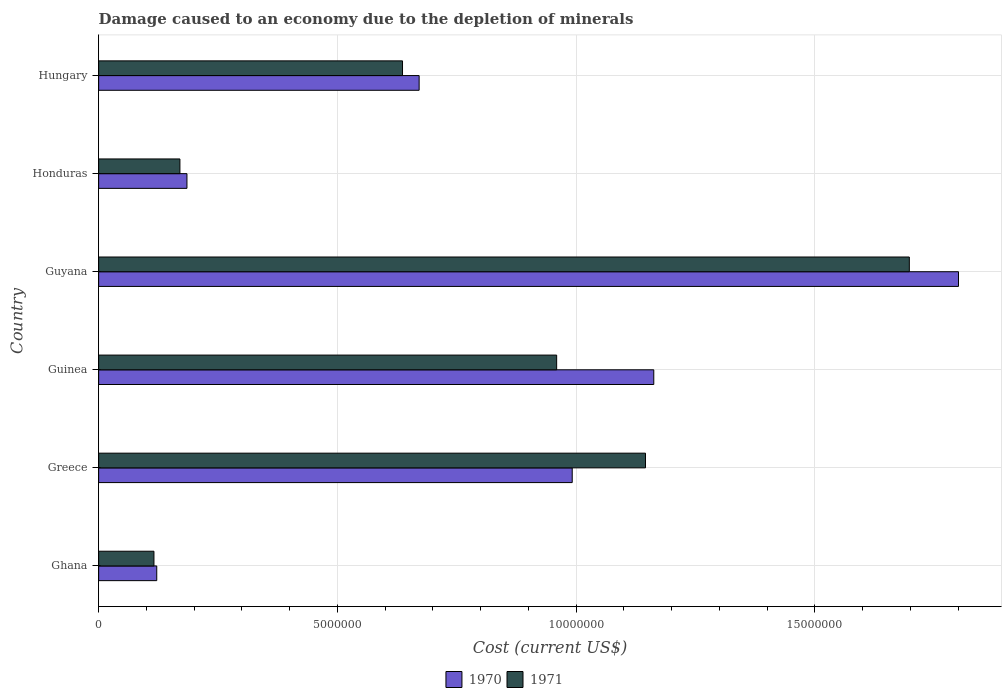How many groups of bars are there?
Give a very brief answer. 6. Are the number of bars per tick equal to the number of legend labels?
Your answer should be very brief. Yes. What is the cost of damage caused due to the depletion of minerals in 1971 in Guinea?
Offer a very short reply. 9.59e+06. Across all countries, what is the maximum cost of damage caused due to the depletion of minerals in 1971?
Your response must be concise. 1.70e+07. Across all countries, what is the minimum cost of damage caused due to the depletion of minerals in 1971?
Keep it short and to the point. 1.16e+06. In which country was the cost of damage caused due to the depletion of minerals in 1970 maximum?
Your answer should be very brief. Guyana. What is the total cost of damage caused due to the depletion of minerals in 1971 in the graph?
Your answer should be compact. 4.72e+07. What is the difference between the cost of damage caused due to the depletion of minerals in 1970 in Ghana and that in Greece?
Give a very brief answer. -8.70e+06. What is the difference between the cost of damage caused due to the depletion of minerals in 1970 in Guyana and the cost of damage caused due to the depletion of minerals in 1971 in Ghana?
Provide a short and direct response. 1.68e+07. What is the average cost of damage caused due to the depletion of minerals in 1970 per country?
Make the answer very short. 8.22e+06. What is the difference between the cost of damage caused due to the depletion of minerals in 1971 and cost of damage caused due to the depletion of minerals in 1970 in Greece?
Offer a terse response. 1.53e+06. In how many countries, is the cost of damage caused due to the depletion of minerals in 1971 greater than 1000000 US$?
Ensure brevity in your answer.  6. What is the ratio of the cost of damage caused due to the depletion of minerals in 1971 in Ghana to that in Honduras?
Make the answer very short. 0.68. Is the cost of damage caused due to the depletion of minerals in 1971 in Honduras less than that in Hungary?
Keep it short and to the point. Yes. Is the difference between the cost of damage caused due to the depletion of minerals in 1971 in Guyana and Hungary greater than the difference between the cost of damage caused due to the depletion of minerals in 1970 in Guyana and Hungary?
Give a very brief answer. No. What is the difference between the highest and the second highest cost of damage caused due to the depletion of minerals in 1971?
Keep it short and to the point. 5.52e+06. What is the difference between the highest and the lowest cost of damage caused due to the depletion of minerals in 1970?
Offer a very short reply. 1.68e+07. In how many countries, is the cost of damage caused due to the depletion of minerals in 1970 greater than the average cost of damage caused due to the depletion of minerals in 1970 taken over all countries?
Your response must be concise. 3. How many bars are there?
Your answer should be very brief. 12. What is the difference between two consecutive major ticks on the X-axis?
Your answer should be very brief. 5.00e+06. Are the values on the major ticks of X-axis written in scientific E-notation?
Offer a terse response. No. Does the graph contain grids?
Provide a succinct answer. Yes. Where does the legend appear in the graph?
Give a very brief answer. Bottom center. How many legend labels are there?
Ensure brevity in your answer.  2. What is the title of the graph?
Keep it short and to the point. Damage caused to an economy due to the depletion of minerals. What is the label or title of the X-axis?
Provide a short and direct response. Cost (current US$). What is the label or title of the Y-axis?
Give a very brief answer. Country. What is the Cost (current US$) of 1970 in Ghana?
Your answer should be very brief. 1.22e+06. What is the Cost (current US$) in 1971 in Ghana?
Your answer should be very brief. 1.16e+06. What is the Cost (current US$) in 1970 in Greece?
Offer a very short reply. 9.92e+06. What is the Cost (current US$) in 1971 in Greece?
Give a very brief answer. 1.15e+07. What is the Cost (current US$) in 1970 in Guinea?
Offer a very short reply. 1.16e+07. What is the Cost (current US$) of 1971 in Guinea?
Make the answer very short. 9.59e+06. What is the Cost (current US$) in 1970 in Guyana?
Ensure brevity in your answer.  1.80e+07. What is the Cost (current US$) in 1971 in Guyana?
Ensure brevity in your answer.  1.70e+07. What is the Cost (current US$) in 1970 in Honduras?
Offer a terse response. 1.85e+06. What is the Cost (current US$) in 1971 in Honduras?
Make the answer very short. 1.70e+06. What is the Cost (current US$) in 1970 in Hungary?
Keep it short and to the point. 6.71e+06. What is the Cost (current US$) in 1971 in Hungary?
Your answer should be compact. 6.36e+06. Across all countries, what is the maximum Cost (current US$) in 1970?
Make the answer very short. 1.80e+07. Across all countries, what is the maximum Cost (current US$) in 1971?
Ensure brevity in your answer.  1.70e+07. Across all countries, what is the minimum Cost (current US$) of 1970?
Provide a short and direct response. 1.22e+06. Across all countries, what is the minimum Cost (current US$) of 1971?
Keep it short and to the point. 1.16e+06. What is the total Cost (current US$) in 1970 in the graph?
Offer a very short reply. 4.93e+07. What is the total Cost (current US$) in 1971 in the graph?
Keep it short and to the point. 4.72e+07. What is the difference between the Cost (current US$) in 1970 in Ghana and that in Greece?
Make the answer very short. -8.70e+06. What is the difference between the Cost (current US$) in 1971 in Ghana and that in Greece?
Offer a terse response. -1.03e+07. What is the difference between the Cost (current US$) in 1970 in Ghana and that in Guinea?
Your response must be concise. -1.04e+07. What is the difference between the Cost (current US$) of 1971 in Ghana and that in Guinea?
Make the answer very short. -8.43e+06. What is the difference between the Cost (current US$) in 1970 in Ghana and that in Guyana?
Offer a very short reply. -1.68e+07. What is the difference between the Cost (current US$) of 1971 in Ghana and that in Guyana?
Keep it short and to the point. -1.58e+07. What is the difference between the Cost (current US$) of 1970 in Ghana and that in Honduras?
Your answer should be compact. -6.33e+05. What is the difference between the Cost (current US$) in 1971 in Ghana and that in Honduras?
Ensure brevity in your answer.  -5.44e+05. What is the difference between the Cost (current US$) in 1970 in Ghana and that in Hungary?
Make the answer very short. -5.49e+06. What is the difference between the Cost (current US$) in 1971 in Ghana and that in Hungary?
Offer a very short reply. -5.20e+06. What is the difference between the Cost (current US$) of 1970 in Greece and that in Guinea?
Make the answer very short. -1.71e+06. What is the difference between the Cost (current US$) in 1971 in Greece and that in Guinea?
Provide a succinct answer. 1.86e+06. What is the difference between the Cost (current US$) in 1970 in Greece and that in Guyana?
Give a very brief answer. -8.09e+06. What is the difference between the Cost (current US$) of 1971 in Greece and that in Guyana?
Keep it short and to the point. -5.52e+06. What is the difference between the Cost (current US$) of 1970 in Greece and that in Honduras?
Your answer should be very brief. 8.07e+06. What is the difference between the Cost (current US$) in 1971 in Greece and that in Honduras?
Keep it short and to the point. 9.75e+06. What is the difference between the Cost (current US$) of 1970 in Greece and that in Hungary?
Provide a short and direct response. 3.21e+06. What is the difference between the Cost (current US$) of 1971 in Greece and that in Hungary?
Keep it short and to the point. 5.09e+06. What is the difference between the Cost (current US$) in 1970 in Guinea and that in Guyana?
Ensure brevity in your answer.  -6.38e+06. What is the difference between the Cost (current US$) of 1971 in Guinea and that in Guyana?
Give a very brief answer. -7.38e+06. What is the difference between the Cost (current US$) in 1970 in Guinea and that in Honduras?
Provide a short and direct response. 9.78e+06. What is the difference between the Cost (current US$) in 1971 in Guinea and that in Honduras?
Ensure brevity in your answer.  7.89e+06. What is the difference between the Cost (current US$) of 1970 in Guinea and that in Hungary?
Your response must be concise. 4.91e+06. What is the difference between the Cost (current US$) in 1971 in Guinea and that in Hungary?
Provide a succinct answer. 3.23e+06. What is the difference between the Cost (current US$) in 1970 in Guyana and that in Honduras?
Keep it short and to the point. 1.62e+07. What is the difference between the Cost (current US$) in 1971 in Guyana and that in Honduras?
Provide a short and direct response. 1.53e+07. What is the difference between the Cost (current US$) of 1970 in Guyana and that in Hungary?
Make the answer very short. 1.13e+07. What is the difference between the Cost (current US$) in 1971 in Guyana and that in Hungary?
Your answer should be compact. 1.06e+07. What is the difference between the Cost (current US$) in 1970 in Honduras and that in Hungary?
Provide a succinct answer. -4.86e+06. What is the difference between the Cost (current US$) in 1971 in Honduras and that in Hungary?
Keep it short and to the point. -4.66e+06. What is the difference between the Cost (current US$) of 1970 in Ghana and the Cost (current US$) of 1971 in Greece?
Offer a very short reply. -1.02e+07. What is the difference between the Cost (current US$) of 1970 in Ghana and the Cost (current US$) of 1971 in Guinea?
Offer a terse response. -8.37e+06. What is the difference between the Cost (current US$) of 1970 in Ghana and the Cost (current US$) of 1971 in Guyana?
Offer a very short reply. -1.58e+07. What is the difference between the Cost (current US$) in 1970 in Ghana and the Cost (current US$) in 1971 in Honduras?
Provide a succinct answer. -4.85e+05. What is the difference between the Cost (current US$) in 1970 in Ghana and the Cost (current US$) in 1971 in Hungary?
Give a very brief answer. -5.15e+06. What is the difference between the Cost (current US$) in 1970 in Greece and the Cost (current US$) in 1971 in Guinea?
Keep it short and to the point. 3.26e+05. What is the difference between the Cost (current US$) of 1970 in Greece and the Cost (current US$) of 1971 in Guyana?
Offer a terse response. -7.06e+06. What is the difference between the Cost (current US$) in 1970 in Greece and the Cost (current US$) in 1971 in Honduras?
Your answer should be very brief. 8.21e+06. What is the difference between the Cost (current US$) of 1970 in Greece and the Cost (current US$) of 1971 in Hungary?
Offer a very short reply. 3.55e+06. What is the difference between the Cost (current US$) of 1970 in Guinea and the Cost (current US$) of 1971 in Guyana?
Offer a very short reply. -5.35e+06. What is the difference between the Cost (current US$) in 1970 in Guinea and the Cost (current US$) in 1971 in Honduras?
Ensure brevity in your answer.  9.92e+06. What is the difference between the Cost (current US$) in 1970 in Guinea and the Cost (current US$) in 1971 in Hungary?
Provide a short and direct response. 5.26e+06. What is the difference between the Cost (current US$) of 1970 in Guyana and the Cost (current US$) of 1971 in Honduras?
Offer a very short reply. 1.63e+07. What is the difference between the Cost (current US$) in 1970 in Guyana and the Cost (current US$) in 1971 in Hungary?
Give a very brief answer. 1.16e+07. What is the difference between the Cost (current US$) of 1970 in Honduras and the Cost (current US$) of 1971 in Hungary?
Provide a short and direct response. -4.51e+06. What is the average Cost (current US$) of 1970 per country?
Your answer should be very brief. 8.22e+06. What is the average Cost (current US$) of 1971 per country?
Your response must be concise. 7.87e+06. What is the difference between the Cost (current US$) in 1970 and Cost (current US$) in 1971 in Ghana?
Your answer should be very brief. 5.86e+04. What is the difference between the Cost (current US$) in 1970 and Cost (current US$) in 1971 in Greece?
Give a very brief answer. -1.53e+06. What is the difference between the Cost (current US$) of 1970 and Cost (current US$) of 1971 in Guinea?
Keep it short and to the point. 2.03e+06. What is the difference between the Cost (current US$) of 1970 and Cost (current US$) of 1971 in Guyana?
Your answer should be very brief. 1.03e+06. What is the difference between the Cost (current US$) of 1970 and Cost (current US$) of 1971 in Honduras?
Make the answer very short. 1.47e+05. What is the difference between the Cost (current US$) in 1970 and Cost (current US$) in 1971 in Hungary?
Your answer should be very brief. 3.48e+05. What is the ratio of the Cost (current US$) of 1970 in Ghana to that in Greece?
Keep it short and to the point. 0.12. What is the ratio of the Cost (current US$) of 1971 in Ghana to that in Greece?
Your response must be concise. 0.1. What is the ratio of the Cost (current US$) of 1970 in Ghana to that in Guinea?
Provide a succinct answer. 0.1. What is the ratio of the Cost (current US$) in 1971 in Ghana to that in Guinea?
Your response must be concise. 0.12. What is the ratio of the Cost (current US$) in 1970 in Ghana to that in Guyana?
Ensure brevity in your answer.  0.07. What is the ratio of the Cost (current US$) of 1971 in Ghana to that in Guyana?
Make the answer very short. 0.07. What is the ratio of the Cost (current US$) of 1970 in Ghana to that in Honduras?
Your answer should be very brief. 0.66. What is the ratio of the Cost (current US$) in 1971 in Ghana to that in Honduras?
Your response must be concise. 0.68. What is the ratio of the Cost (current US$) in 1970 in Ghana to that in Hungary?
Offer a terse response. 0.18. What is the ratio of the Cost (current US$) of 1971 in Ghana to that in Hungary?
Your answer should be compact. 0.18. What is the ratio of the Cost (current US$) of 1970 in Greece to that in Guinea?
Your answer should be compact. 0.85. What is the ratio of the Cost (current US$) of 1971 in Greece to that in Guinea?
Your answer should be compact. 1.19. What is the ratio of the Cost (current US$) of 1970 in Greece to that in Guyana?
Provide a short and direct response. 0.55. What is the ratio of the Cost (current US$) in 1971 in Greece to that in Guyana?
Provide a succinct answer. 0.67. What is the ratio of the Cost (current US$) in 1970 in Greece to that in Honduras?
Ensure brevity in your answer.  5.36. What is the ratio of the Cost (current US$) in 1971 in Greece to that in Honduras?
Make the answer very short. 6.73. What is the ratio of the Cost (current US$) in 1970 in Greece to that in Hungary?
Ensure brevity in your answer.  1.48. What is the ratio of the Cost (current US$) of 1971 in Greece to that in Hungary?
Offer a very short reply. 1.8. What is the ratio of the Cost (current US$) of 1970 in Guinea to that in Guyana?
Give a very brief answer. 0.65. What is the ratio of the Cost (current US$) in 1971 in Guinea to that in Guyana?
Give a very brief answer. 0.56. What is the ratio of the Cost (current US$) in 1970 in Guinea to that in Honduras?
Give a very brief answer. 6.29. What is the ratio of the Cost (current US$) of 1971 in Guinea to that in Honduras?
Offer a very short reply. 5.63. What is the ratio of the Cost (current US$) in 1970 in Guinea to that in Hungary?
Ensure brevity in your answer.  1.73. What is the ratio of the Cost (current US$) of 1971 in Guinea to that in Hungary?
Provide a succinct answer. 1.51. What is the ratio of the Cost (current US$) of 1970 in Guyana to that in Honduras?
Make the answer very short. 9.74. What is the ratio of the Cost (current US$) of 1971 in Guyana to that in Honduras?
Make the answer very short. 9.97. What is the ratio of the Cost (current US$) in 1970 in Guyana to that in Hungary?
Your answer should be compact. 2.68. What is the ratio of the Cost (current US$) in 1971 in Guyana to that in Hungary?
Make the answer very short. 2.67. What is the ratio of the Cost (current US$) of 1970 in Honduras to that in Hungary?
Your answer should be compact. 0.28. What is the ratio of the Cost (current US$) in 1971 in Honduras to that in Hungary?
Give a very brief answer. 0.27. What is the difference between the highest and the second highest Cost (current US$) in 1970?
Your answer should be very brief. 6.38e+06. What is the difference between the highest and the second highest Cost (current US$) in 1971?
Provide a short and direct response. 5.52e+06. What is the difference between the highest and the lowest Cost (current US$) of 1970?
Your response must be concise. 1.68e+07. What is the difference between the highest and the lowest Cost (current US$) in 1971?
Your response must be concise. 1.58e+07. 